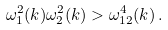Convert formula to latex. <formula><loc_0><loc_0><loc_500><loc_500>\omega _ { 1 } ^ { 2 } ( k ) \omega _ { 2 } ^ { 2 } ( k ) > \omega _ { 1 2 } ^ { 4 } ( k ) \, .</formula> 